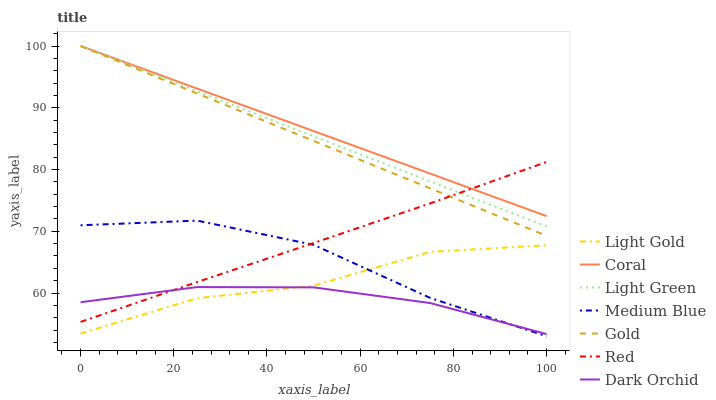Does Medium Blue have the minimum area under the curve?
Answer yes or no. No. Does Medium Blue have the maximum area under the curve?
Answer yes or no. No. Is Medium Blue the smoothest?
Answer yes or no. No. Is Coral the roughest?
Answer yes or no. No. Does Coral have the lowest value?
Answer yes or no. No. Does Medium Blue have the highest value?
Answer yes or no. No. Is Medium Blue less than Gold?
Answer yes or no. Yes. Is Red greater than Light Gold?
Answer yes or no. Yes. Does Medium Blue intersect Gold?
Answer yes or no. No. 